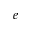Convert formula to latex. <formula><loc_0><loc_0><loc_500><loc_500>e</formula> 